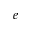Convert formula to latex. <formula><loc_0><loc_0><loc_500><loc_500>e</formula> 